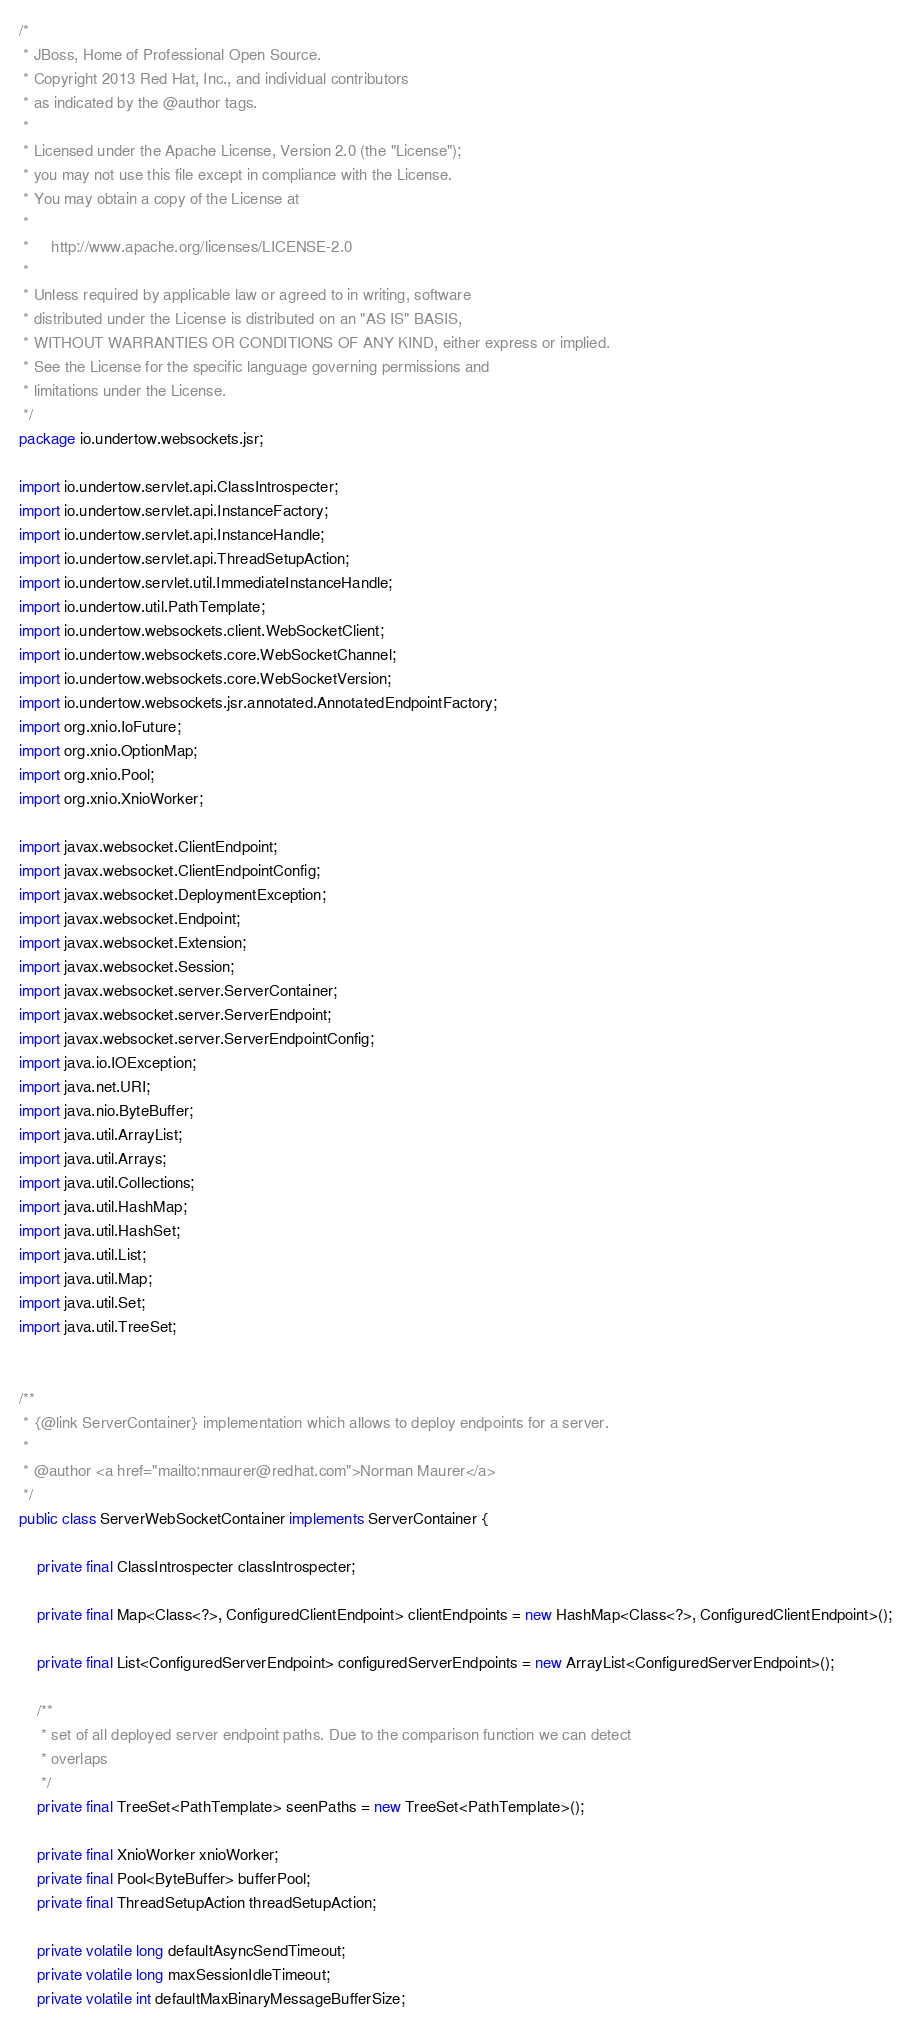<code> <loc_0><loc_0><loc_500><loc_500><_Java_>/*
 * JBoss, Home of Professional Open Source.
 * Copyright 2013 Red Hat, Inc., and individual contributors
 * as indicated by the @author tags.
 *
 * Licensed under the Apache License, Version 2.0 (the "License");
 * you may not use this file except in compliance with the License.
 * You may obtain a copy of the License at
 *
 *     http://www.apache.org/licenses/LICENSE-2.0
 *
 * Unless required by applicable law or agreed to in writing, software
 * distributed under the License is distributed on an "AS IS" BASIS,
 * WITHOUT WARRANTIES OR CONDITIONS OF ANY KIND, either express or implied.
 * See the License for the specific language governing permissions and
 * limitations under the License.
 */
package io.undertow.websockets.jsr;

import io.undertow.servlet.api.ClassIntrospecter;
import io.undertow.servlet.api.InstanceFactory;
import io.undertow.servlet.api.InstanceHandle;
import io.undertow.servlet.api.ThreadSetupAction;
import io.undertow.servlet.util.ImmediateInstanceHandle;
import io.undertow.util.PathTemplate;
import io.undertow.websockets.client.WebSocketClient;
import io.undertow.websockets.core.WebSocketChannel;
import io.undertow.websockets.core.WebSocketVersion;
import io.undertow.websockets.jsr.annotated.AnnotatedEndpointFactory;
import org.xnio.IoFuture;
import org.xnio.OptionMap;
import org.xnio.Pool;
import org.xnio.XnioWorker;

import javax.websocket.ClientEndpoint;
import javax.websocket.ClientEndpointConfig;
import javax.websocket.DeploymentException;
import javax.websocket.Endpoint;
import javax.websocket.Extension;
import javax.websocket.Session;
import javax.websocket.server.ServerContainer;
import javax.websocket.server.ServerEndpoint;
import javax.websocket.server.ServerEndpointConfig;
import java.io.IOException;
import java.net.URI;
import java.nio.ByteBuffer;
import java.util.ArrayList;
import java.util.Arrays;
import java.util.Collections;
import java.util.HashMap;
import java.util.HashSet;
import java.util.List;
import java.util.Map;
import java.util.Set;
import java.util.TreeSet;


/**
 * {@link ServerContainer} implementation which allows to deploy endpoints for a server.
 *
 * @author <a href="mailto:nmaurer@redhat.com">Norman Maurer</a>
 */
public class ServerWebSocketContainer implements ServerContainer {

    private final ClassIntrospecter classIntrospecter;

    private final Map<Class<?>, ConfiguredClientEndpoint> clientEndpoints = new HashMap<Class<?>, ConfiguredClientEndpoint>();

    private final List<ConfiguredServerEndpoint> configuredServerEndpoints = new ArrayList<ConfiguredServerEndpoint>();

    /**
     * set of all deployed server endpoint paths. Due to the comparison function we can detect
     * overlaps
     */
    private final TreeSet<PathTemplate> seenPaths = new TreeSet<PathTemplate>();

    private final XnioWorker xnioWorker;
    private final Pool<ByteBuffer> bufferPool;
    private final ThreadSetupAction threadSetupAction;

    private volatile long defaultAsyncSendTimeout;
    private volatile long maxSessionIdleTimeout;
    private volatile int defaultMaxBinaryMessageBufferSize;</code> 